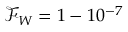Convert formula to latex. <formula><loc_0><loc_0><loc_500><loc_500>\mathcal { F } _ { W } = 1 - 1 0 ^ { - 7 }</formula> 